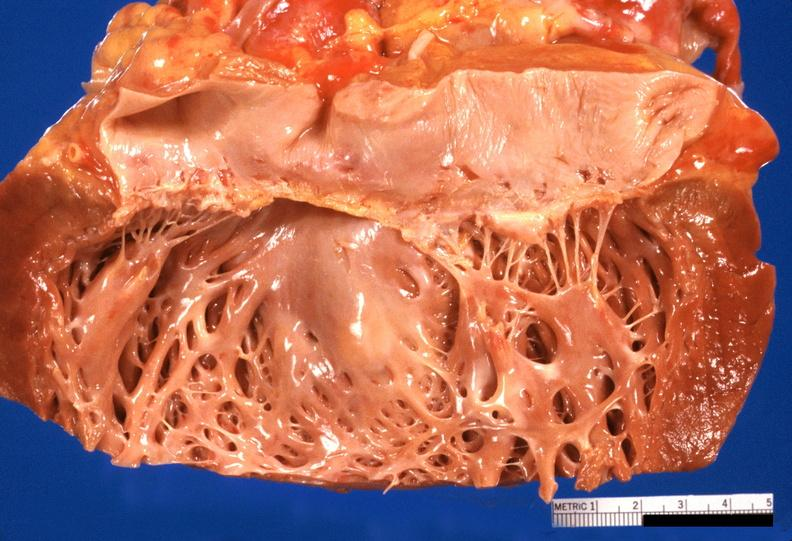what does this image show?
Answer the question using a single word or phrase. Heart 